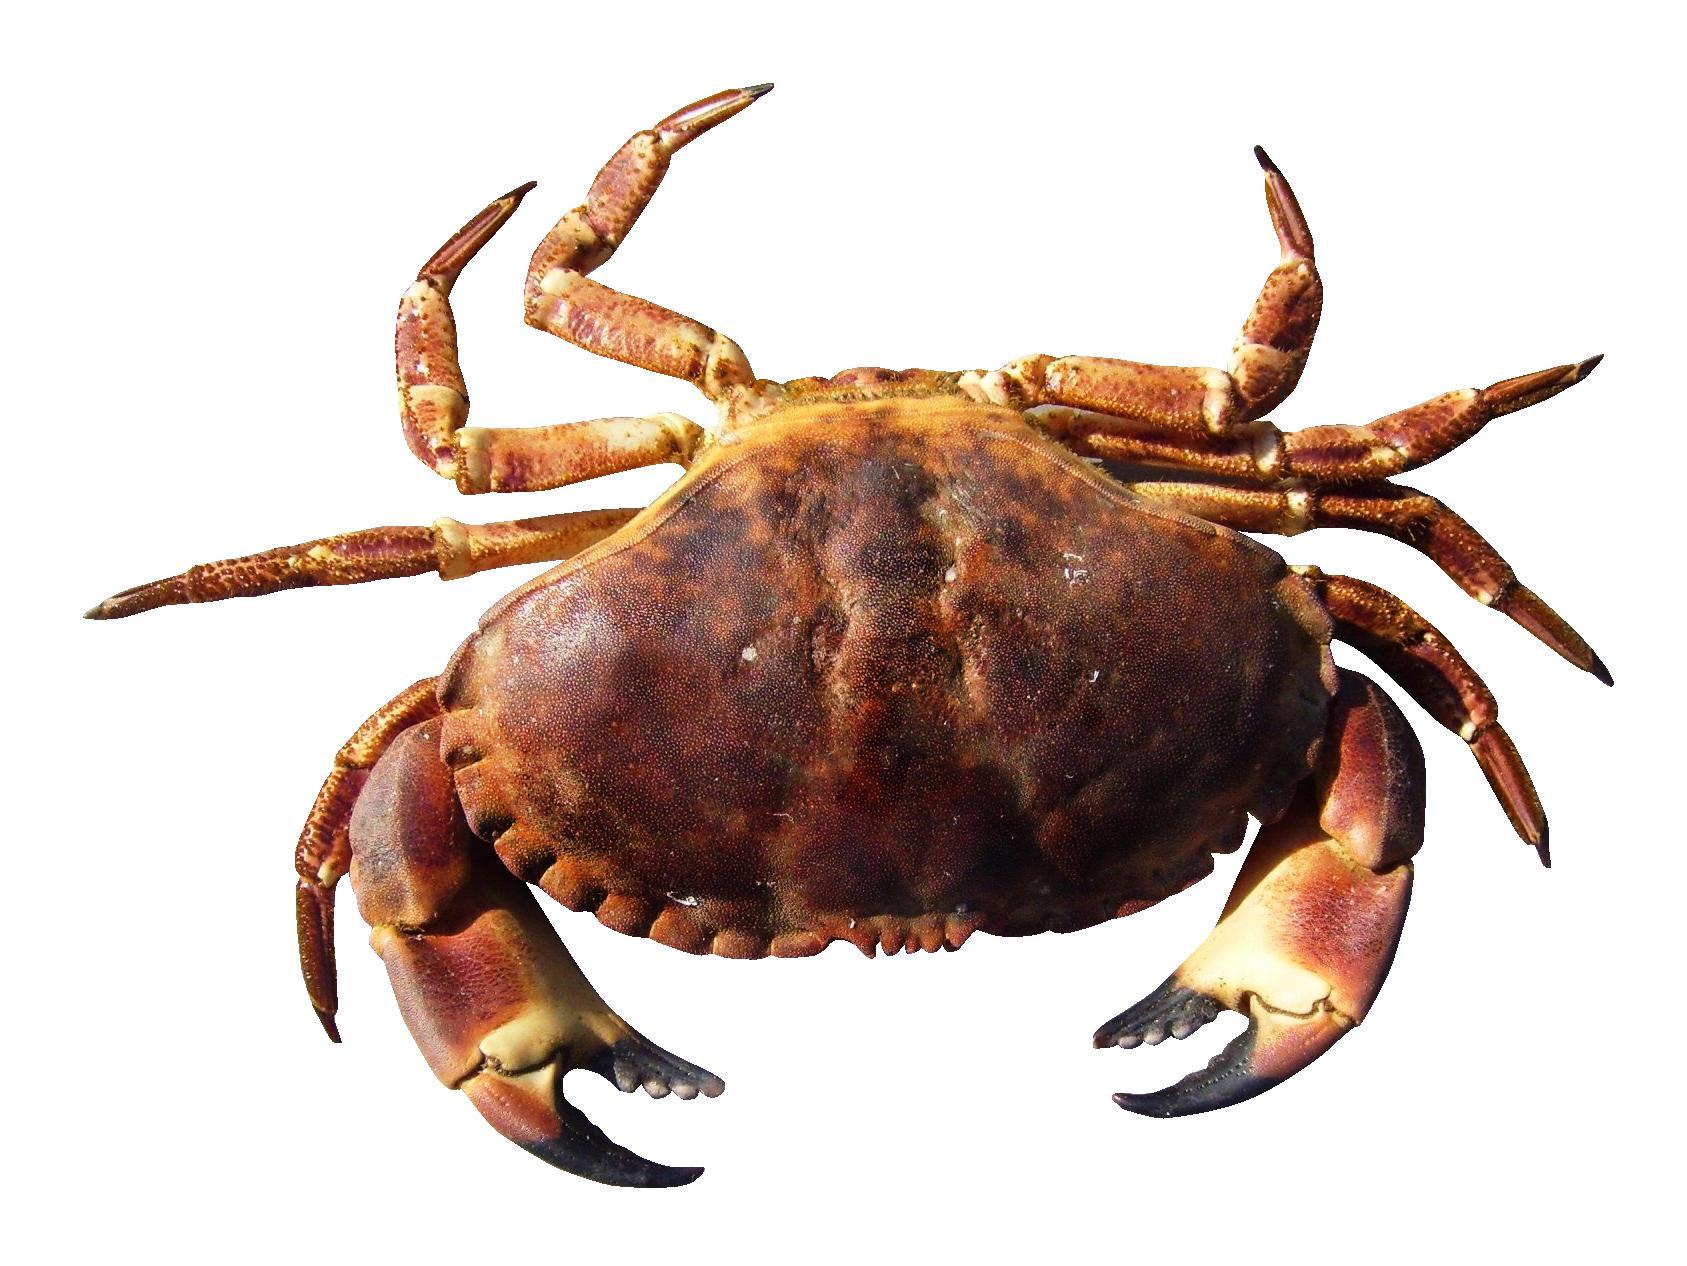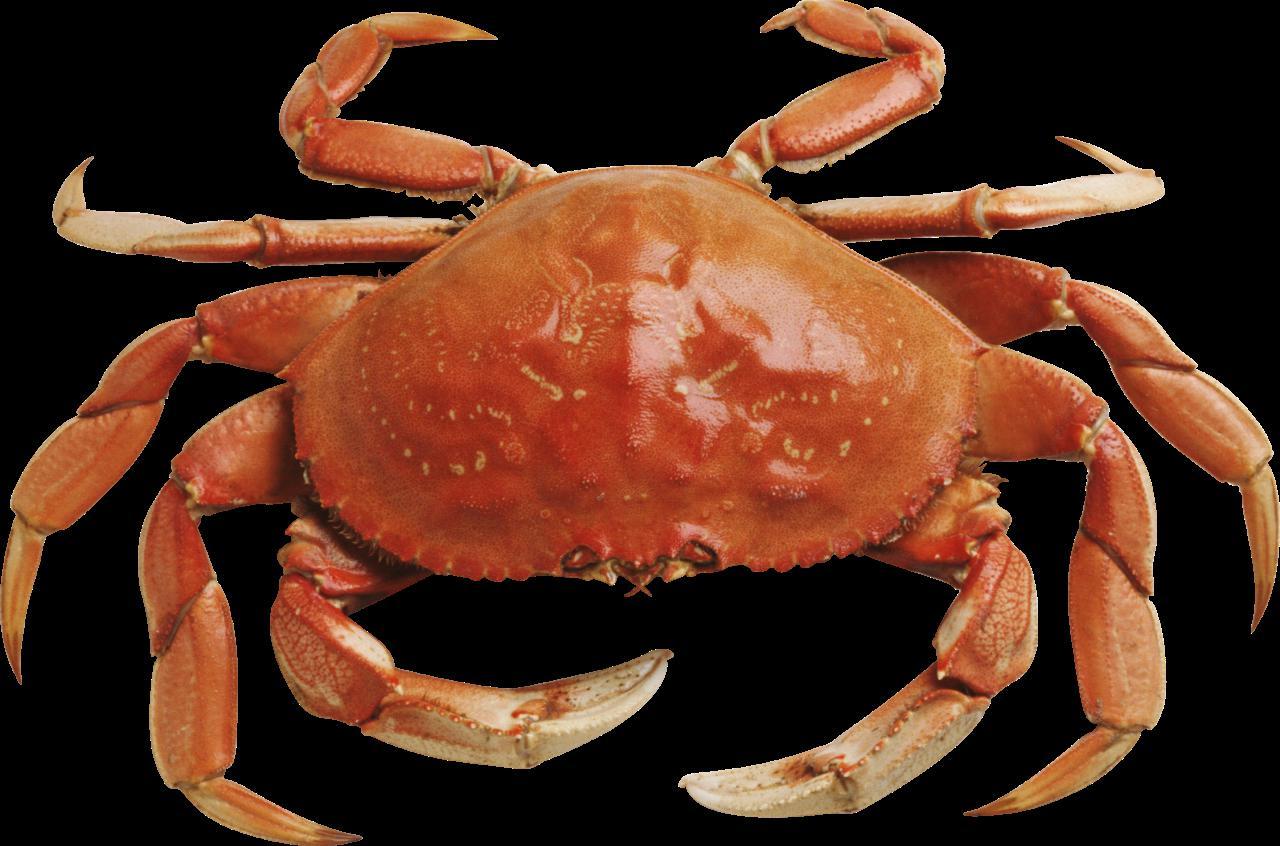The first image is the image on the left, the second image is the image on the right. For the images shown, is this caption "Both crabs are orange." true? Answer yes or no. Yes. 